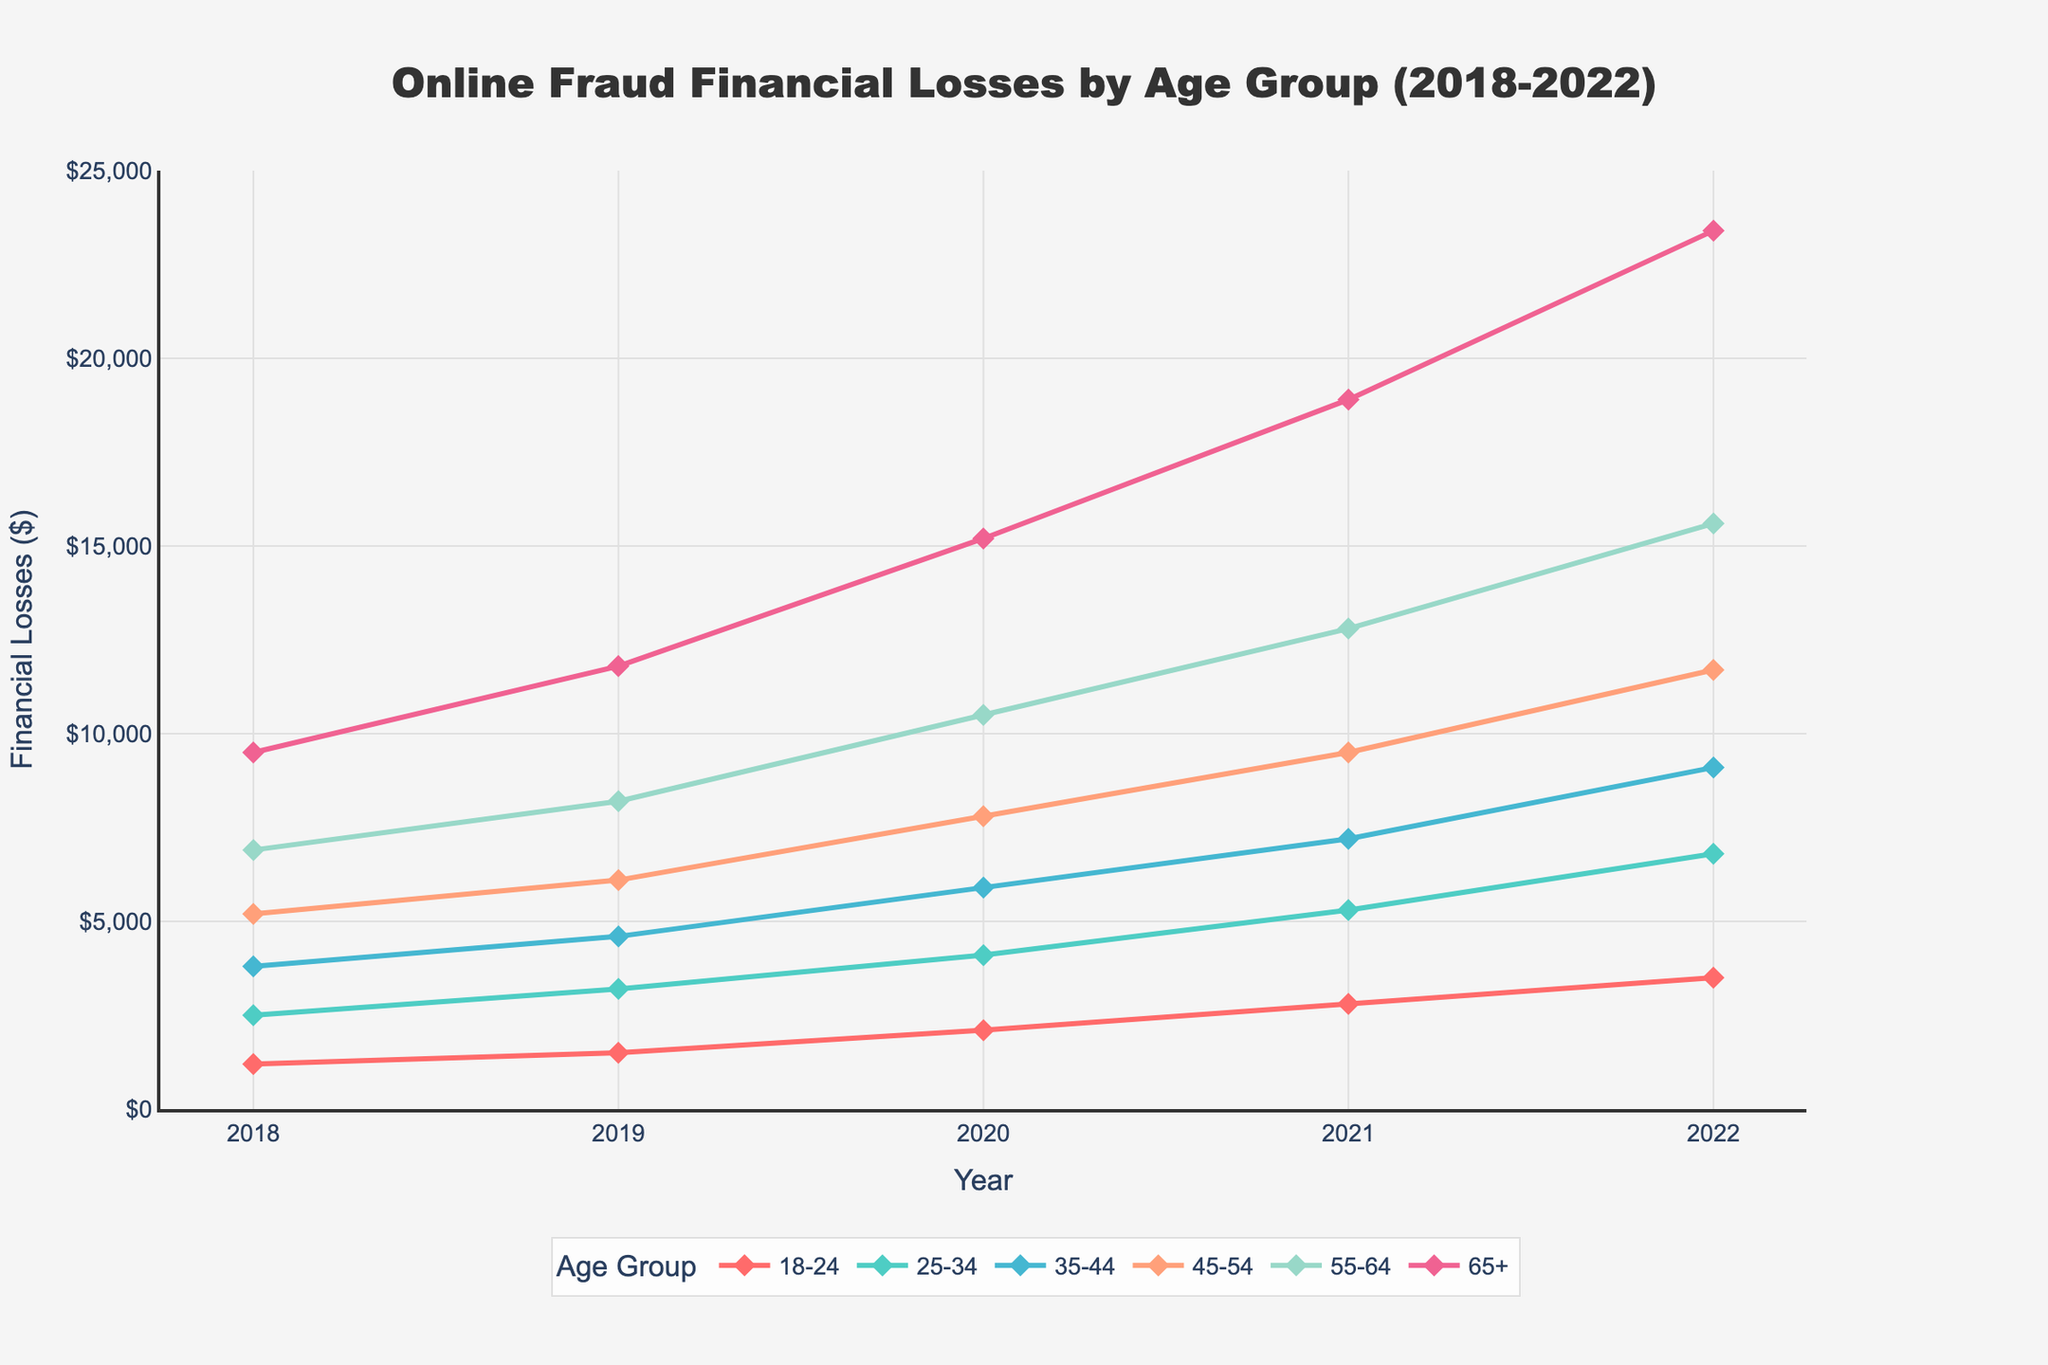Which age group experienced the highest financial loss in 2022? To find the answer, look at the year 2022 on the x-axis and identify the age group with the highest endpoint on the y-axis. The highest y-value is $23400 for the 65+ age group.
Answer: 65+ Which age group had the smallest increase in financial losses from 2018 to 2022? To determine this, calculate the difference between the 2022 and 2018 values for each age group and compare them. Only the 18-24 age group has the smallest increase from $1200 to $3500, which is an increase of $2300.
Answer: 18-24 What is the average financial loss in 2022 for all age groups? To find the average, sum up the 2022 financial losses for all age groups and then divide by 6 (the number of age groups). The values are $3500, $6800, $9100, $11700, $15600, and $23400, giving a total of $70100. Dividing by 6, the average is $11683.33.
Answer: $11683.33 How did the financial losses for the 35-44 age group change from 2019 to 2021? For 2019, the financial loss is $4600, and for 2021, it is $7200. Compute the difference: $7200 - $4600 = $2600.
Answer: $2600 increase Which two years saw the largest increase in financial losses for the 65+ age group? Look at the financial loss values for the 65+ age group: $9500 (2018), $11800 (2019), $15200 (2020), $18900 (2021), $23400 (2022). The biggest difference is between $18900 (2021) and $23400 (2022), resulting in a $4500 increase.
Answer: 2021 to 2022 In which year did the 45-54 age group surpass $10000 in financial losses? Look at the financial loss values for the 45-54 age group from 2018 to 2022: $5200 (2018), $6100 (2019), $7800 (2020), $9500 (2021), $11700 (2022). The age group surpasses $10000 in 2022.
Answer: 2022 